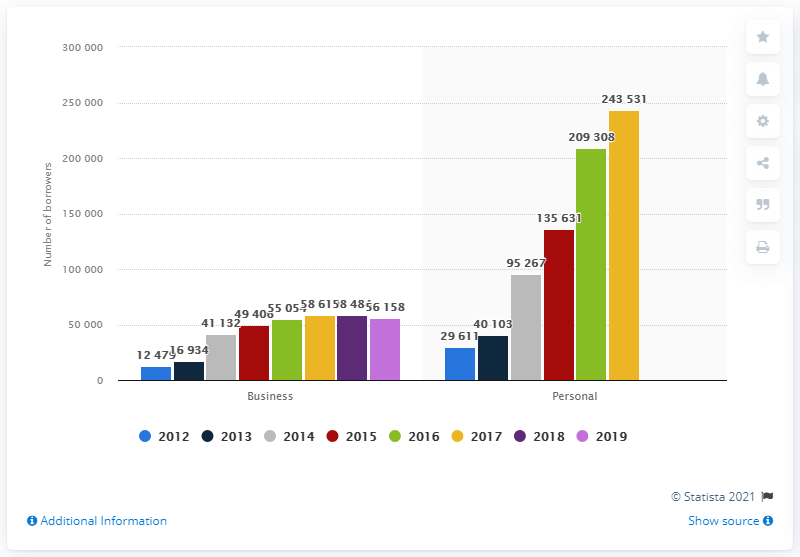List a handful of essential elements in this visual. In 2017, a total of 58,619 business loans were granted to Spanish microfinance institutions (MFIs). By 2019, there were 56,158 active business microloans recipients. In 2017, there were 243,531 borrowers who took credit for personal use. 